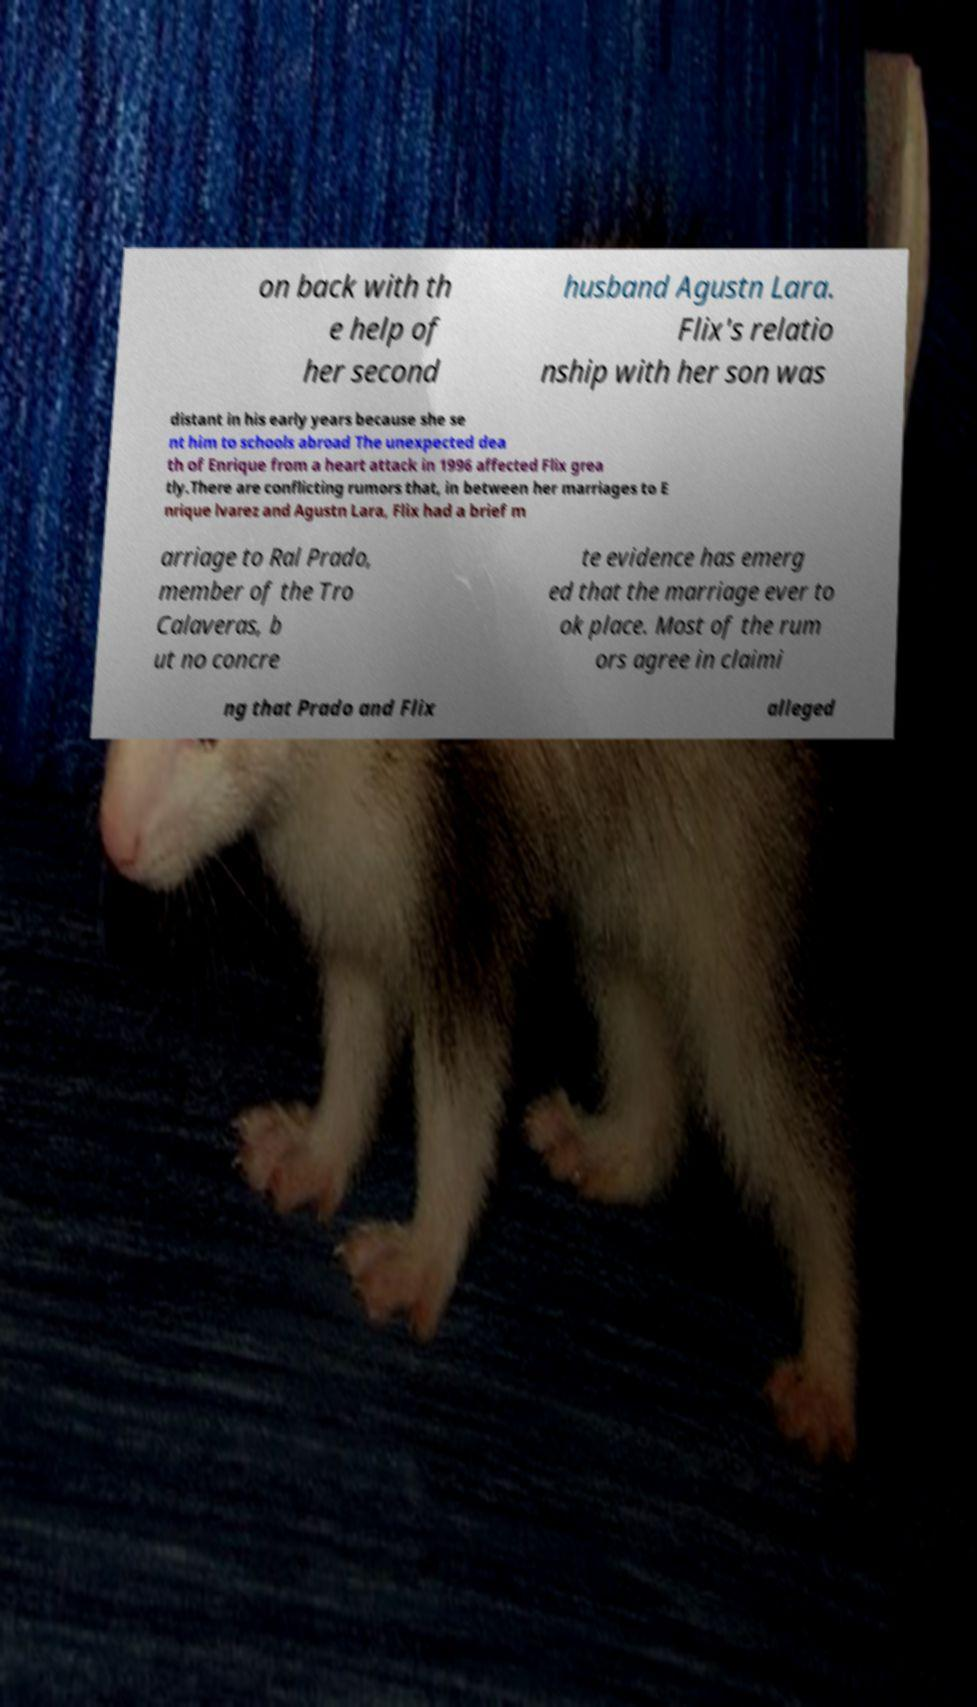Could you extract and type out the text from this image? on back with th e help of her second husband Agustn Lara. Flix's relatio nship with her son was distant in his early years because she se nt him to schools abroad The unexpected dea th of Enrique from a heart attack in 1996 affected Flix grea tly.There are conflicting rumors that, in between her marriages to E nrique lvarez and Agustn Lara, Flix had a brief m arriage to Ral Prado, member of the Tro Calaveras, b ut no concre te evidence has emerg ed that the marriage ever to ok place. Most of the rum ors agree in claimi ng that Prado and Flix alleged 